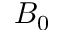Convert formula to latex. <formula><loc_0><loc_0><loc_500><loc_500>B _ { 0 }</formula> 